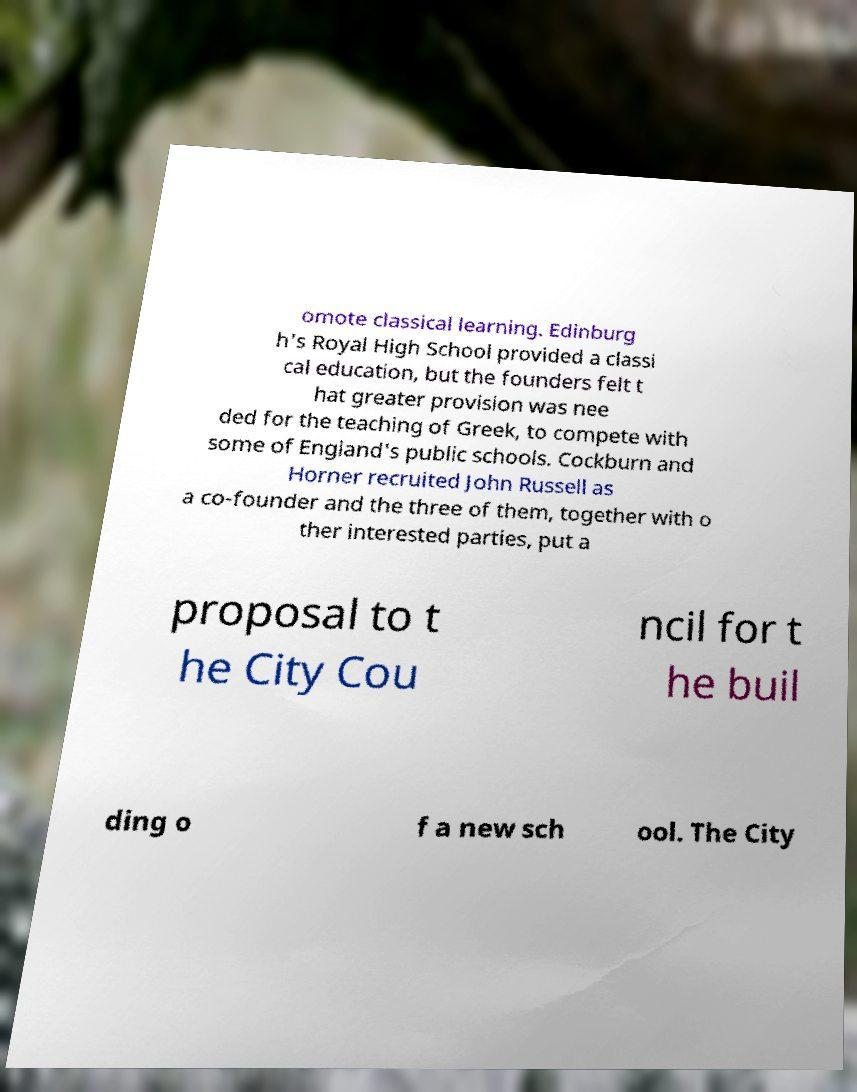Please identify and transcribe the text found in this image. omote classical learning. Edinburg h's Royal High School provided a classi cal education, but the founders felt t hat greater provision was nee ded for the teaching of Greek, to compete with some of England's public schools. Cockburn and Horner recruited John Russell as a co-founder and the three of them, together with o ther interested parties, put a proposal to t he City Cou ncil for t he buil ding o f a new sch ool. The City 